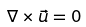Convert formula to latex. <formula><loc_0><loc_0><loc_500><loc_500>\nabla \times \vec { u } = 0</formula> 